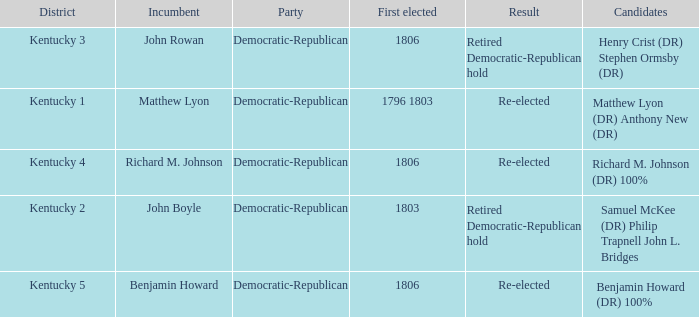Name the first elected for kentucky 1 1796 1803. 